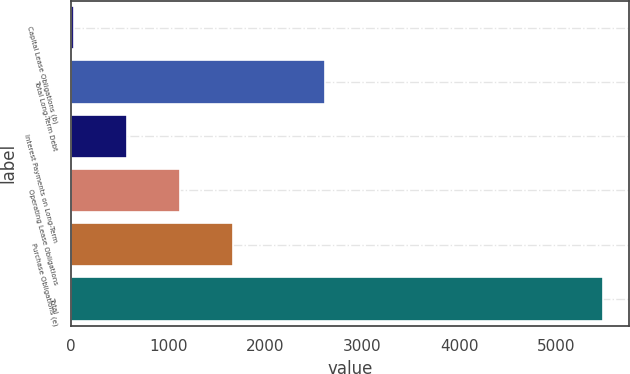<chart> <loc_0><loc_0><loc_500><loc_500><bar_chart><fcel>Capital Lease Obligations (b)<fcel>Total Long-Term Debt<fcel>Interest Payments on Long-Term<fcel>Operating Lease Obligations<fcel>Purchase Obligations (e)<fcel>Total<nl><fcel>28.6<fcel>2619.3<fcel>573.51<fcel>1118.42<fcel>1663.33<fcel>5477.7<nl></chart> 